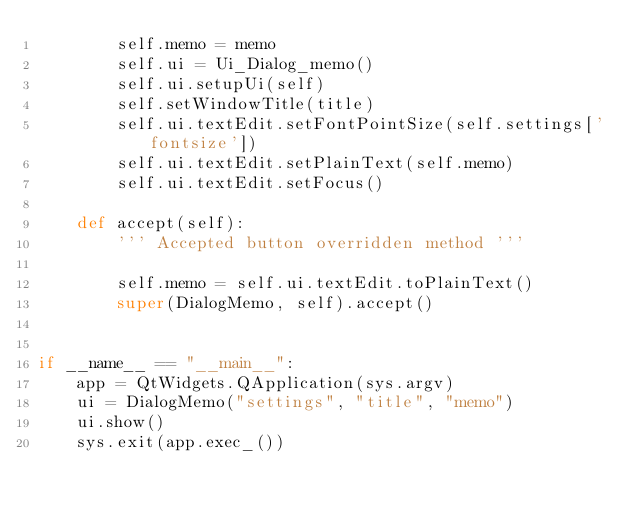<code> <loc_0><loc_0><loc_500><loc_500><_Python_>        self.memo = memo
        self.ui = Ui_Dialog_memo()
        self.ui.setupUi(self)
        self.setWindowTitle(title)
        self.ui.textEdit.setFontPointSize(self.settings['fontsize'])
        self.ui.textEdit.setPlainText(self.memo)
        self.ui.textEdit.setFocus()

    def accept(self):
        ''' Accepted button overridden method '''

        self.memo = self.ui.textEdit.toPlainText()
        super(DialogMemo, self).accept()


if __name__ == "__main__":
    app = QtWidgets.QApplication(sys.argv)
    ui = DialogMemo("settings", "title", "memo")
    ui.show()
    sys.exit(app.exec_())

</code> 